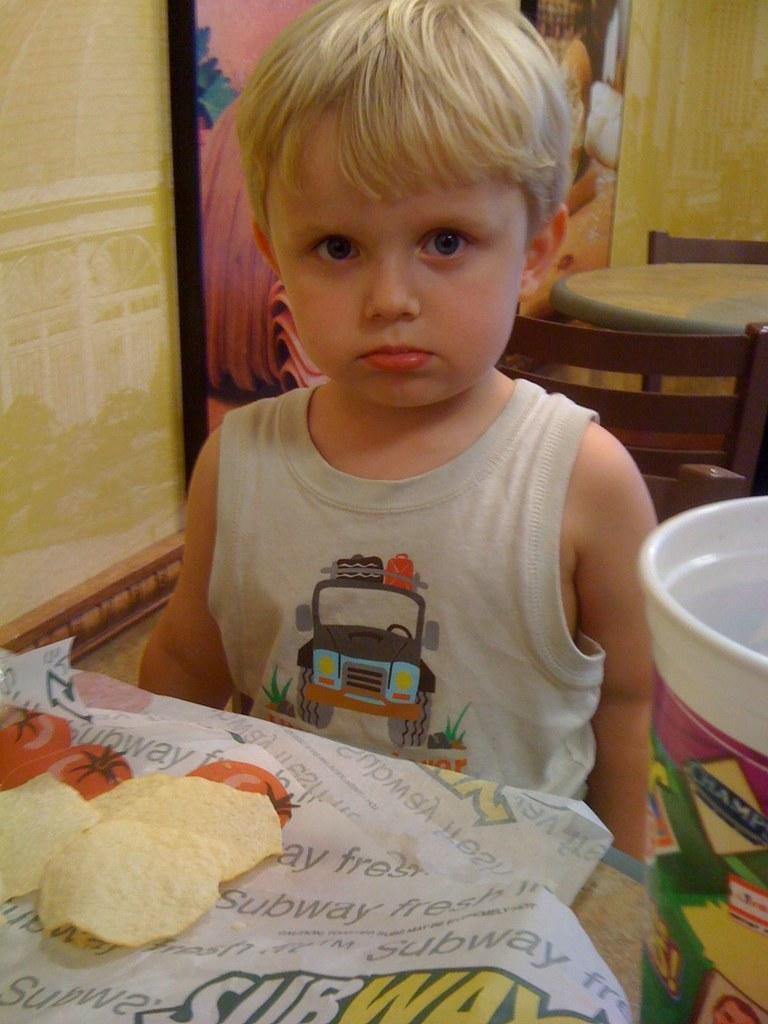Could you give a brief overview of what you see in this image? In this image i can see a child wearing a white inner is sitting in front in front of a table. On the table i can see few papers and few food items. In the background i can see few chairs, a table, the wall and a photo frame. 